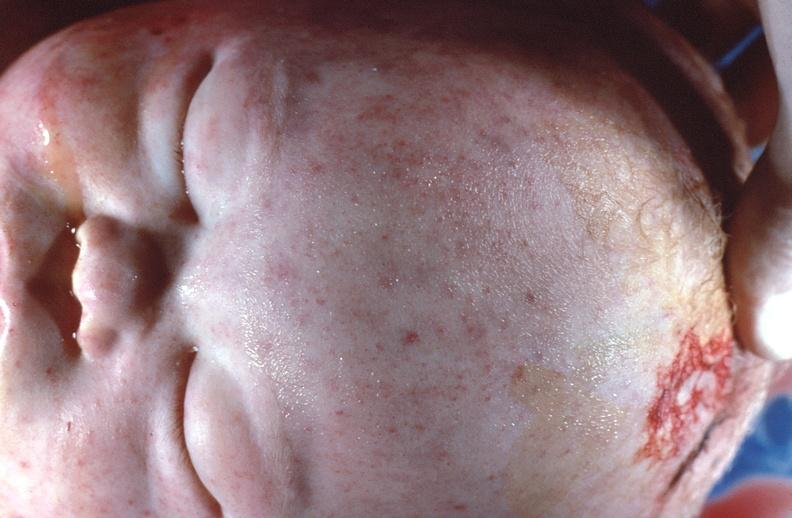why does this image show gram negative septicemia?
Answer the question using a single word or phrase. Due to scalp electrode in a neonate 